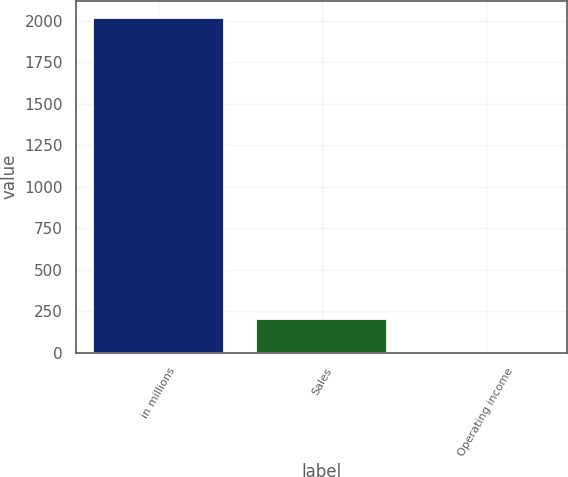Convert chart to OTSL. <chart><loc_0><loc_0><loc_500><loc_500><bar_chart><fcel>in millions<fcel>Sales<fcel>Operating income<nl><fcel>2018<fcel>202.7<fcel>1<nl></chart> 